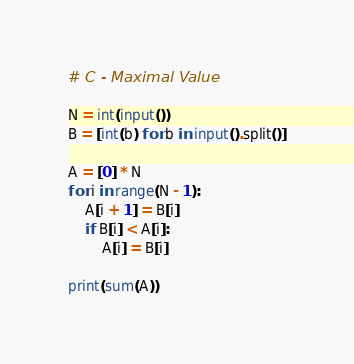Convert code to text. <code><loc_0><loc_0><loc_500><loc_500><_Python_># C - Maximal Value

N = int(input())
B = [int(b) for b in input().split()]

A = [0] * N
for i in range(N - 1):
    A[i + 1] = B[i]
    if B[i] < A[i]:
        A[i] = B[i]

print(sum(A))
</code> 